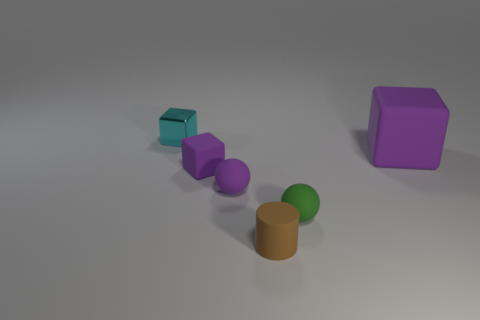Subtract all purple cylinders. How many purple blocks are left? 2 Subtract all small blocks. How many blocks are left? 1 Subtract all gray cubes. Subtract all blue spheres. How many cubes are left? 3 Add 1 small green spheres. How many objects exist? 7 Subtract all cylinders. How many objects are left? 5 Add 4 purple matte balls. How many purple matte balls exist? 5 Subtract 0 cyan cylinders. How many objects are left? 6 Subtract all tiny brown matte cylinders. Subtract all tiny blue cylinders. How many objects are left? 5 Add 4 tiny purple spheres. How many tiny purple spheres are left? 5 